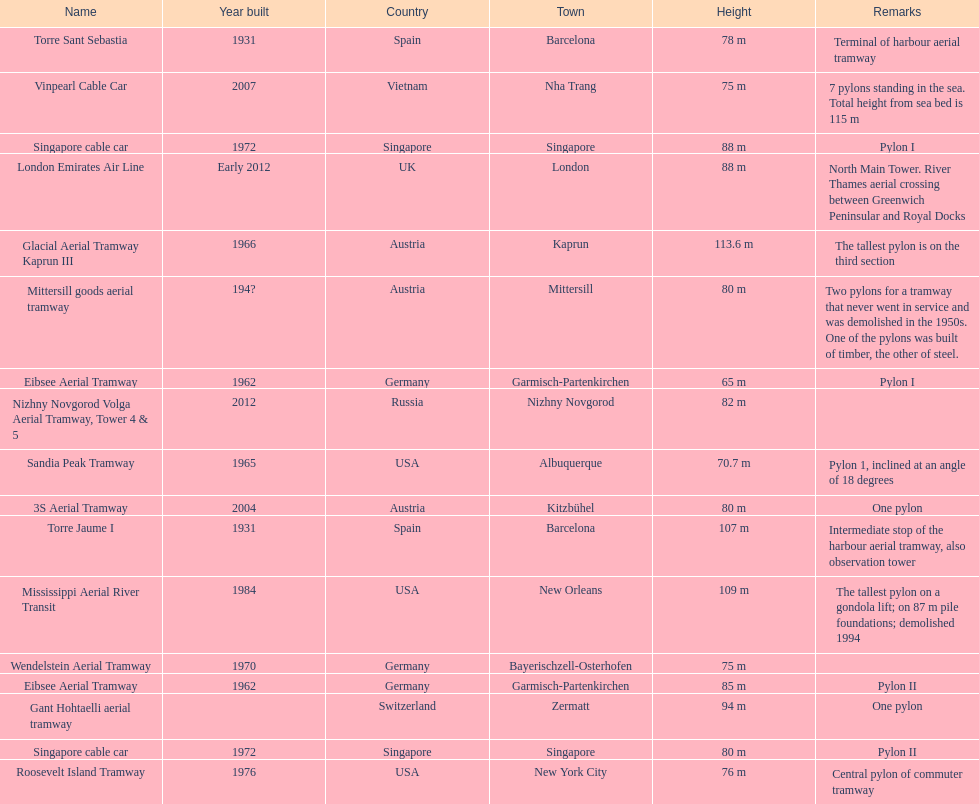What year was the last pylon in germany built? 1970. 